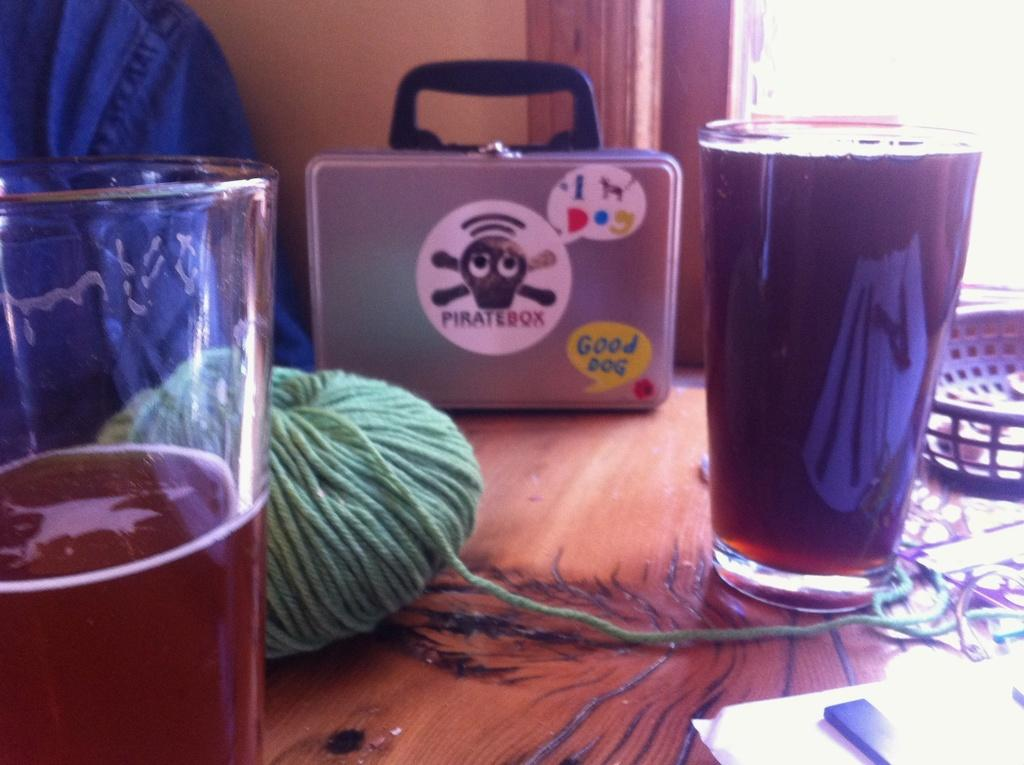<image>
Summarize the visual content of the image. An assortment of items is on a wood table, including a metallic looking lunch box or briefcase that says "Piratebox" on it. 